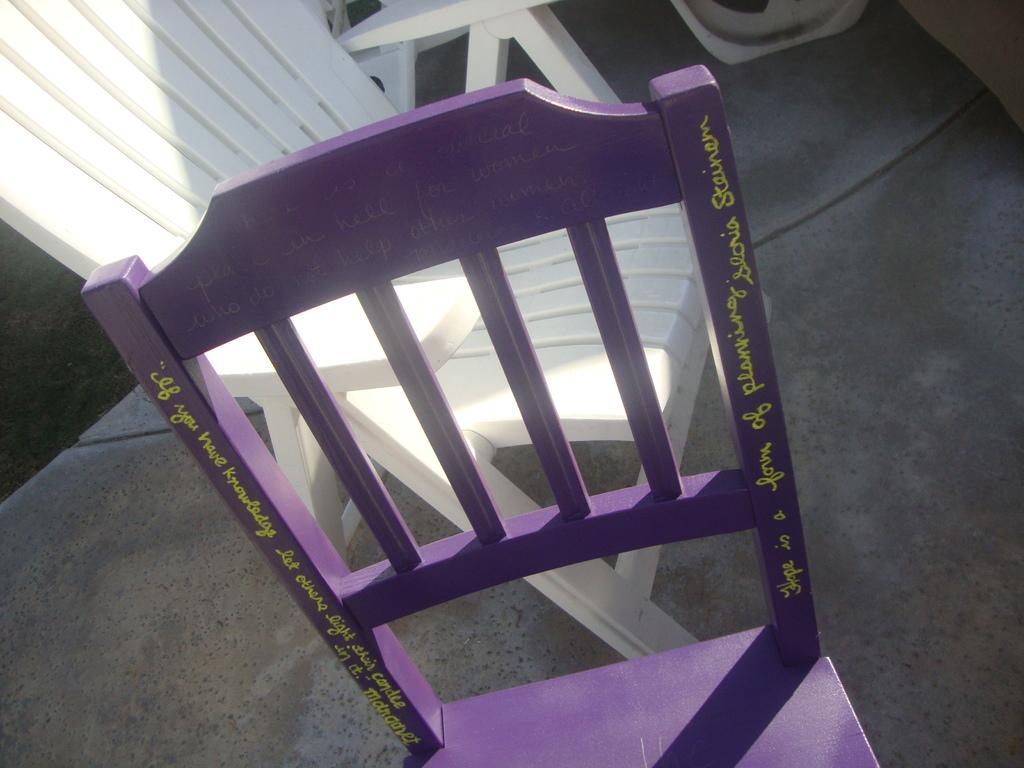What type of furniture can be seen in the image? There are chairs in the image. Can you describe any additional features of the chairs? There is text on at least one of the chairs. How many sisters are sitting on the chairs in the image? There is no information about sisters or anyone sitting on the chairs in the image. 